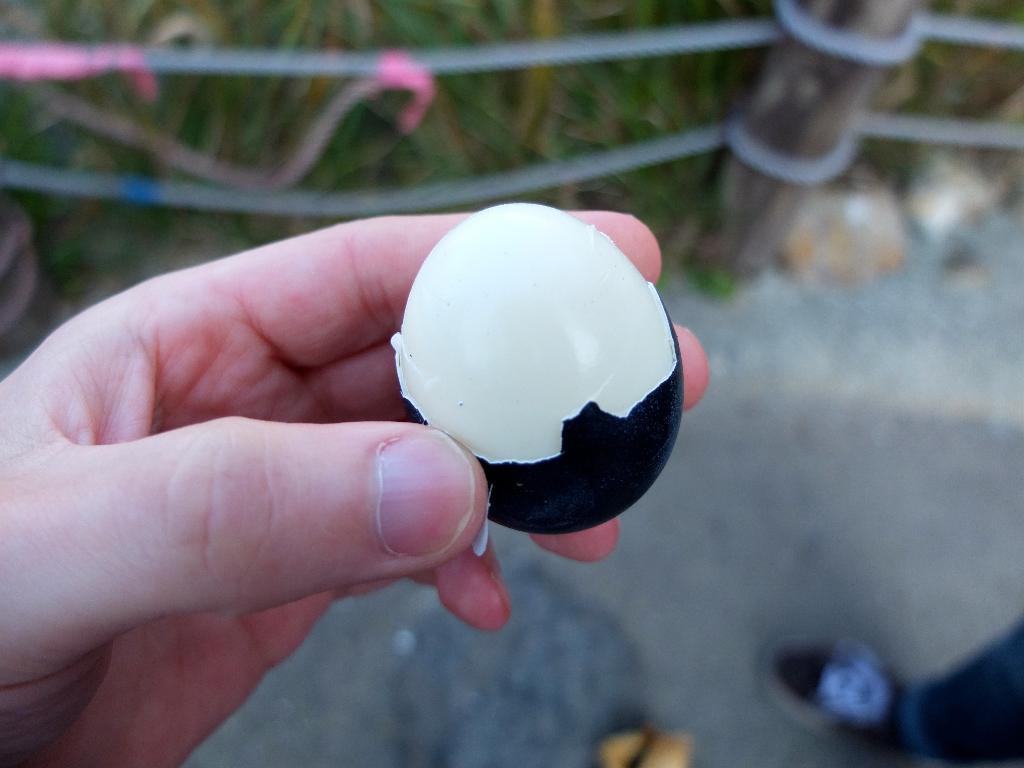In one or two sentences, can you explain what this image depicts? In this picture, we see the hand of the human holding the egg. At the bottom, we see the road and the leg of the human who is wearing the shoes. In the background, we see the wooden fence and plants or grass. This picture is blurred in the background. 